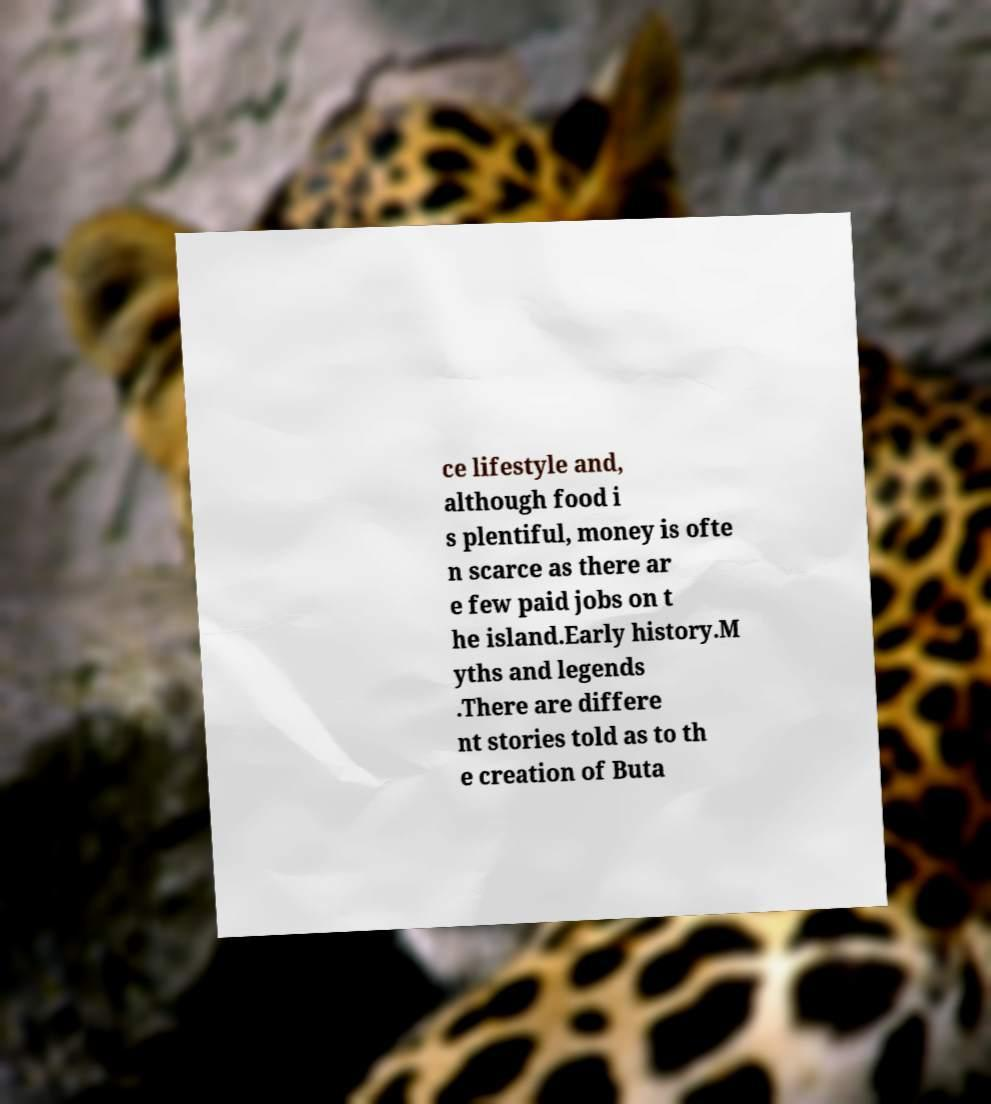Could you assist in decoding the text presented in this image and type it out clearly? ce lifestyle and, although food i s plentiful, money is ofte n scarce as there ar e few paid jobs on t he island.Early history.M yths and legends .There are differe nt stories told as to th e creation of Buta 